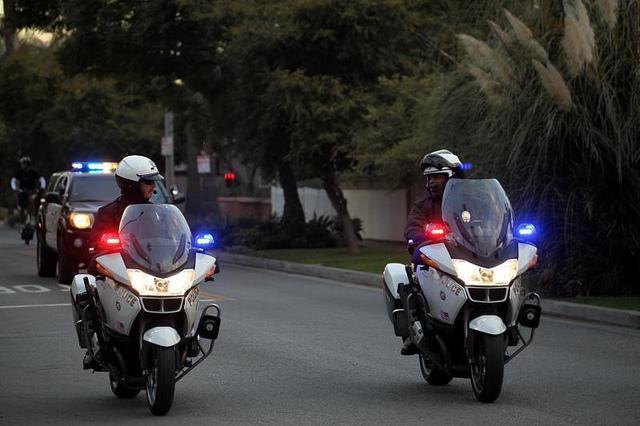What color is the officer riding on the police motorcycle to the left?
Pick the correct solution from the four options below to address the question.
Options: Black, green, white, purple. White. 